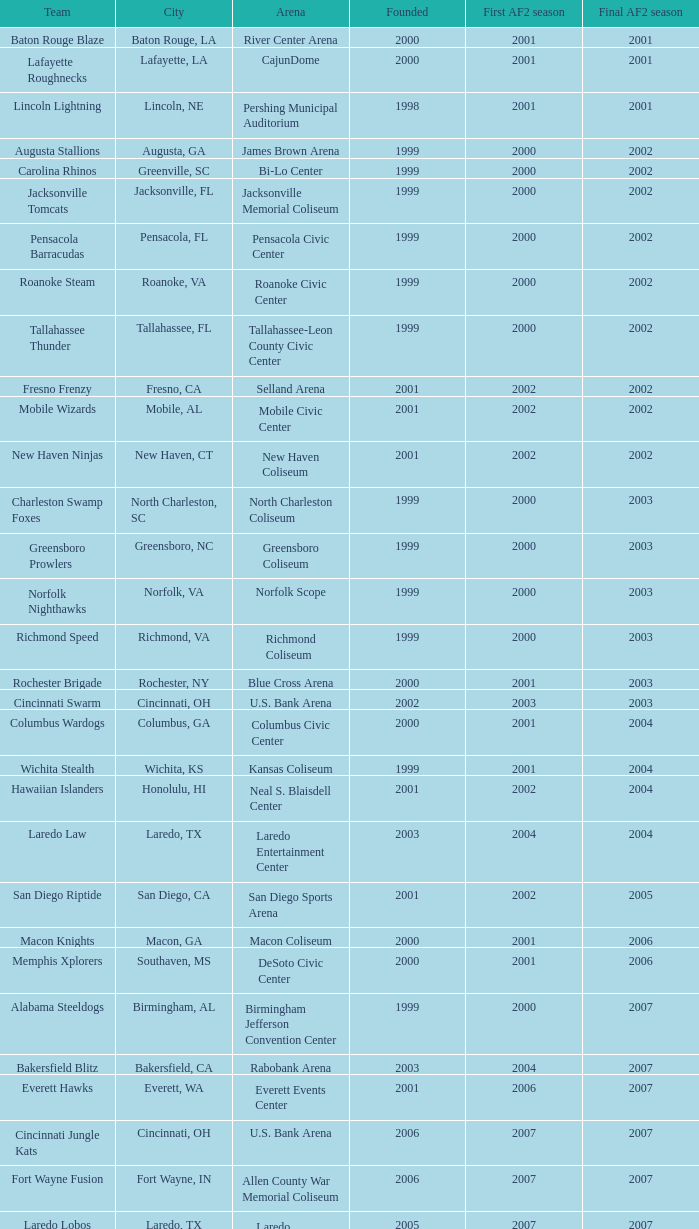Can you give me this table as a dict? {'header': ['Team', 'City', 'Arena', 'Founded', 'First AF2 season', 'Final AF2 season'], 'rows': [['Baton Rouge Blaze', 'Baton Rouge, LA', 'River Center Arena', '2000', '2001', '2001'], ['Lafayette Roughnecks', 'Lafayette, LA', 'CajunDome', '2000', '2001', '2001'], ['Lincoln Lightning', 'Lincoln, NE', 'Pershing Municipal Auditorium', '1998', '2001', '2001'], ['Augusta Stallions', 'Augusta, GA', 'James Brown Arena', '1999', '2000', '2002'], ['Carolina Rhinos', 'Greenville, SC', 'Bi-Lo Center', '1999', '2000', '2002'], ['Jacksonville Tomcats', 'Jacksonville, FL', 'Jacksonville Memorial Coliseum', '1999', '2000', '2002'], ['Pensacola Barracudas', 'Pensacola, FL', 'Pensacola Civic Center', '1999', '2000', '2002'], ['Roanoke Steam', 'Roanoke, VA', 'Roanoke Civic Center', '1999', '2000', '2002'], ['Tallahassee Thunder', 'Tallahassee, FL', 'Tallahassee-Leon County Civic Center', '1999', '2000', '2002'], ['Fresno Frenzy', 'Fresno, CA', 'Selland Arena', '2001', '2002', '2002'], ['Mobile Wizards', 'Mobile, AL', 'Mobile Civic Center', '2001', '2002', '2002'], ['New Haven Ninjas', 'New Haven, CT', 'New Haven Coliseum', '2001', '2002', '2002'], ['Charleston Swamp Foxes', 'North Charleston, SC', 'North Charleston Coliseum', '1999', '2000', '2003'], ['Greensboro Prowlers', 'Greensboro, NC', 'Greensboro Coliseum', '1999', '2000', '2003'], ['Norfolk Nighthawks', 'Norfolk, VA', 'Norfolk Scope', '1999', '2000', '2003'], ['Richmond Speed', 'Richmond, VA', 'Richmond Coliseum', '1999', '2000', '2003'], ['Rochester Brigade', 'Rochester, NY', 'Blue Cross Arena', '2000', '2001', '2003'], ['Cincinnati Swarm', 'Cincinnati, OH', 'U.S. Bank Arena', '2002', '2003', '2003'], ['Columbus Wardogs', 'Columbus, GA', 'Columbus Civic Center', '2000', '2001', '2004'], ['Wichita Stealth', 'Wichita, KS', 'Kansas Coliseum', '1999', '2001', '2004'], ['Hawaiian Islanders', 'Honolulu, HI', 'Neal S. Blaisdell Center', '2001', '2002', '2004'], ['Laredo Law', 'Laredo, TX', 'Laredo Entertainment Center', '2003', '2004', '2004'], ['San Diego Riptide', 'San Diego, CA', 'San Diego Sports Arena', '2001', '2002', '2005'], ['Macon Knights', 'Macon, GA', 'Macon Coliseum', '2000', '2001', '2006'], ['Memphis Xplorers', 'Southaven, MS', 'DeSoto Civic Center', '2000', '2001', '2006'], ['Alabama Steeldogs', 'Birmingham, AL', 'Birmingham Jefferson Convention Center', '1999', '2000', '2007'], ['Bakersfield Blitz', 'Bakersfield, CA', 'Rabobank Arena', '2003', '2004', '2007'], ['Everett Hawks', 'Everett, WA', 'Everett Events Center', '2001', '2006', '2007'], ['Cincinnati Jungle Kats', 'Cincinnati, OH', 'U.S. Bank Arena', '2006', '2007', '2007'], ['Fort Wayne Fusion', 'Fort Wayne, IN', 'Allen County War Memorial Coliseum', '2006', '2007', '2007'], ['Laredo Lobos', 'Laredo, TX', 'Laredo Entertainment Center', '2005', '2007', '2007'], ['Louisville Fire', 'Louisville, KY', 'Freedom Hall', '2000', '2001', '2008'], ['Lubbock Renegades', 'Lubbock, TX', 'City Bank Coliseum', '2006', '2007', '2008'], ['Texas Copperheads', 'Cypress, TX', 'Richard E. Berry Educational Support Center', '2005', '2007', '2008'], ['Austin Wranglers', 'Austin, TX', 'Frank Erwin Center', '2003', '2008', '2008'], ['Daytona Beach ThunderBirds', 'Daytona Beach, FL', 'Ocean Center', '2005', '2008', '2008'], ['Mahoning Valley Thunder', 'Youngstown, OH', 'Covelli Centre', '2007', '2007', '2009'], ['Arkansas Twisters', 'North Little Rock, Arkansas', 'Verizon Arena', '1999', '2000', '2009'], ['Central Valley Coyotes', 'Fresno, California', 'Selland Arena', '2001', '2002', '2009'], ['Kentucky Horsemen', 'Lexington, Kentucky', 'Rupp Arena', '2002', '2008', '2009'], ['Tri-Cities Fever', 'Kennewick, Washington', 'Toyota Center', '2004', '2007', '2009']]} How many initiated years experienced a last af2 season preceding 2009 where the location was the bi-lo center and the opening af2 season was earlier than 2000? 0.0. 